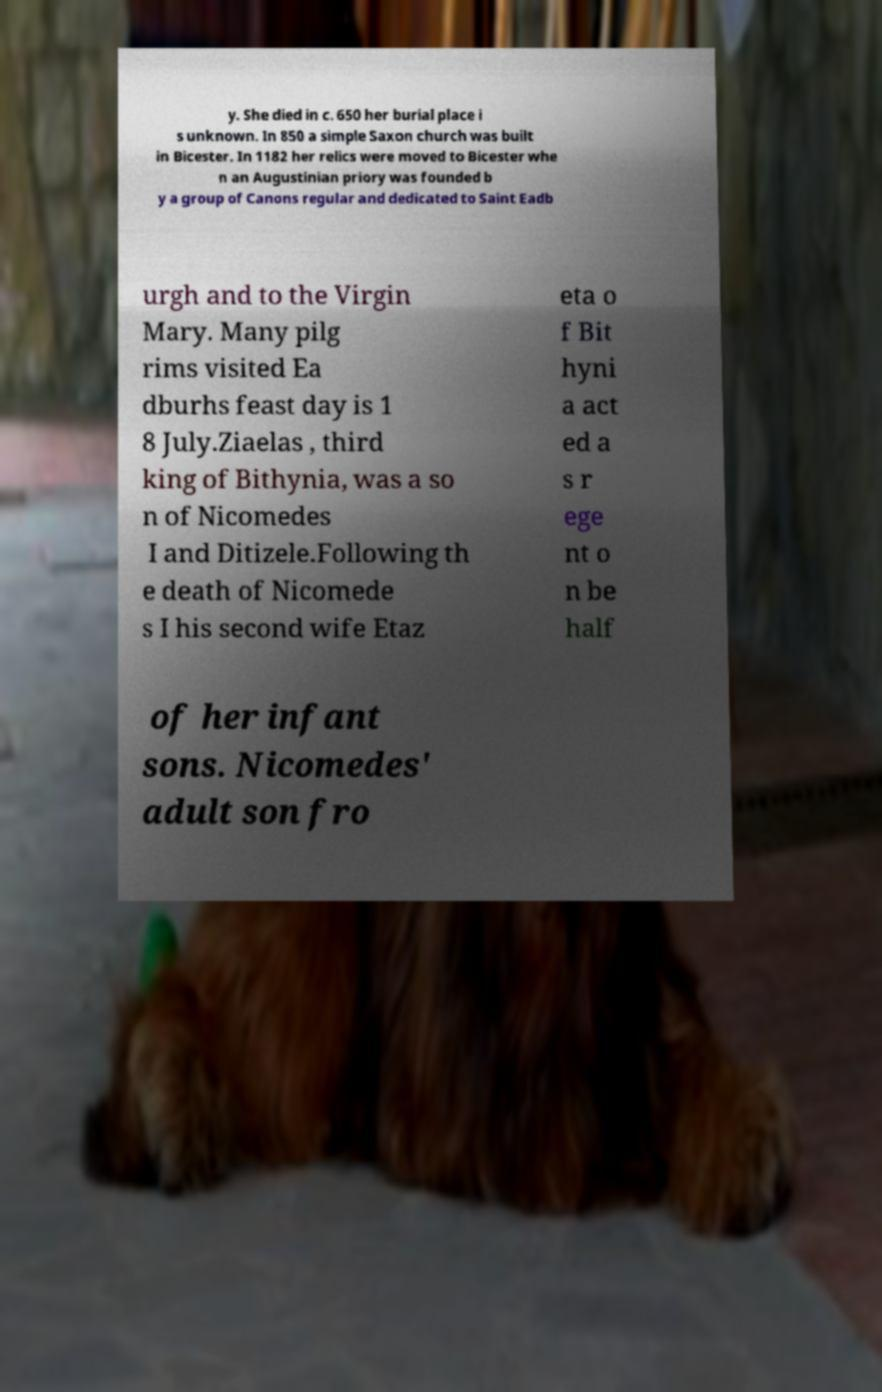There's text embedded in this image that I need extracted. Can you transcribe it verbatim? y. She died in c. 650 her burial place i s unknown. In 850 a simple Saxon church was built in Bicester. In 1182 her relics were moved to Bicester whe n an Augustinian priory was founded b y a group of Canons regular and dedicated to Saint Eadb urgh and to the Virgin Mary. Many pilg rims visited Ea dburhs feast day is 1 8 July.Ziaelas , third king of Bithynia, was a so n of Nicomedes I and Ditizele.Following th e death of Nicomede s I his second wife Etaz eta o f Bit hyni a act ed a s r ege nt o n be half of her infant sons. Nicomedes' adult son fro 